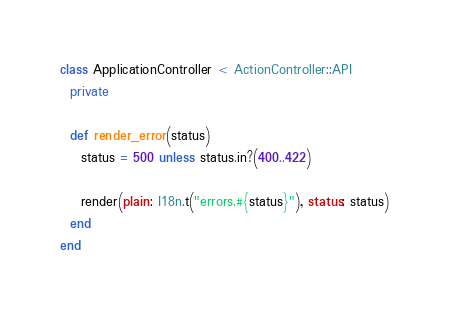<code> <loc_0><loc_0><loc_500><loc_500><_Ruby_>class ApplicationController < ActionController::API
  private

  def render_error(status)
    status = 500 unless status.in?(400..422)

    render(plain: I18n.t("errors.#{status}"), status: status)
  end
end
</code> 